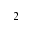<formula> <loc_0><loc_0><loc_500><loc_500>_ { 2 }</formula> 